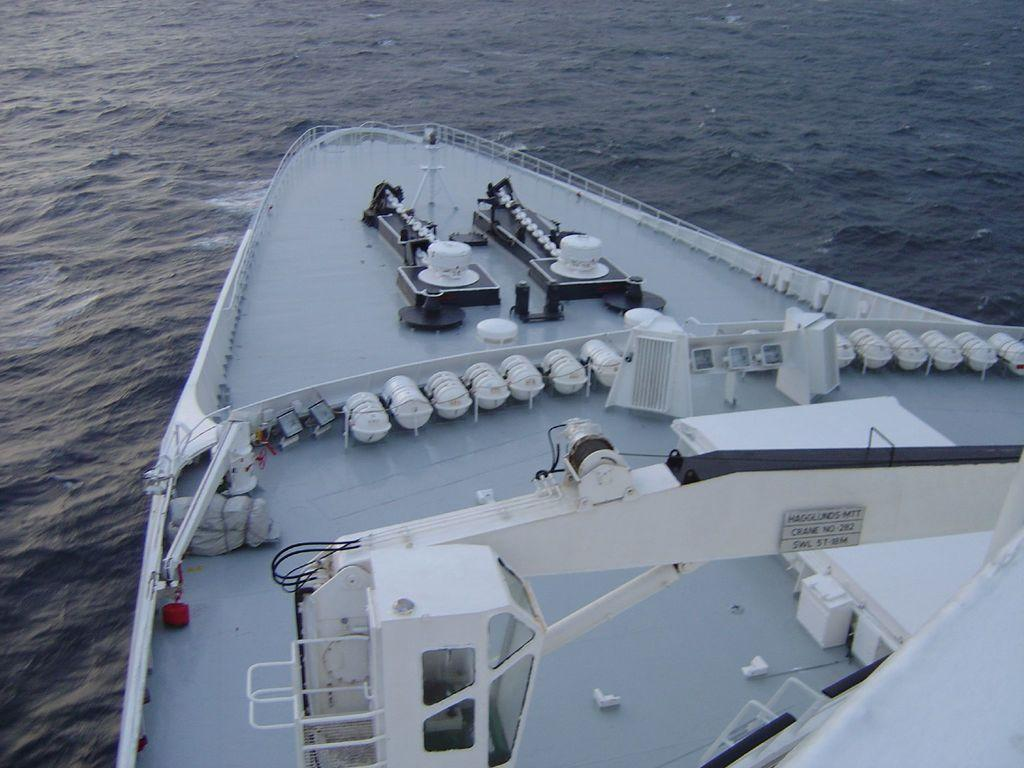What is the main subject in the foreground of the image? There is a truncated ship in the foreground of the image. What can be seen in the background of the image? There is water visible in the image. What type of sack can be seen reacting to the agreement in the image? There is no sack or agreement present in the image; it features a truncated ship and water. 